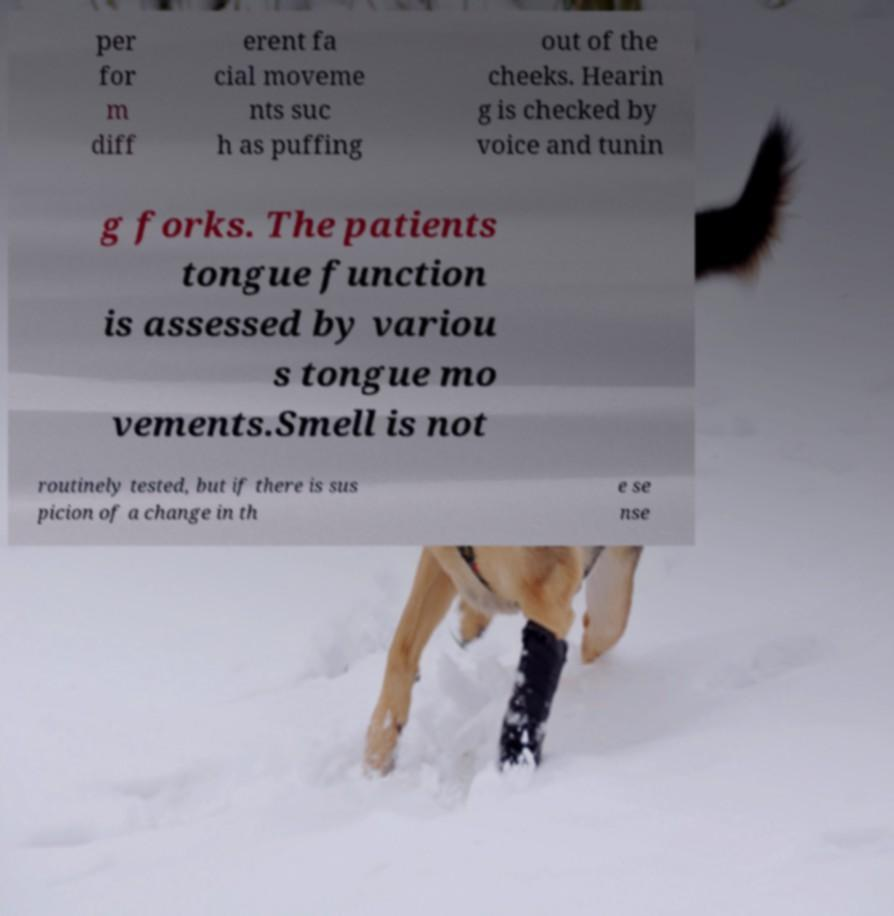For documentation purposes, I need the text within this image transcribed. Could you provide that? per for m diff erent fa cial moveme nts suc h as puffing out of the cheeks. Hearin g is checked by voice and tunin g forks. The patients tongue function is assessed by variou s tongue mo vements.Smell is not routinely tested, but if there is sus picion of a change in th e se nse 